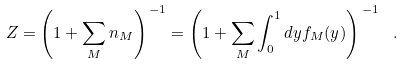Convert formula to latex. <formula><loc_0><loc_0><loc_500><loc_500>Z = \left ( 1 + \sum _ { M } n _ { M } \right ) ^ { \, - 1 } = \left ( 1 + \sum _ { M } \int _ { 0 } ^ { 1 } d y f _ { M } ( y ) \right ) ^ { \, - 1 } \ .</formula> 